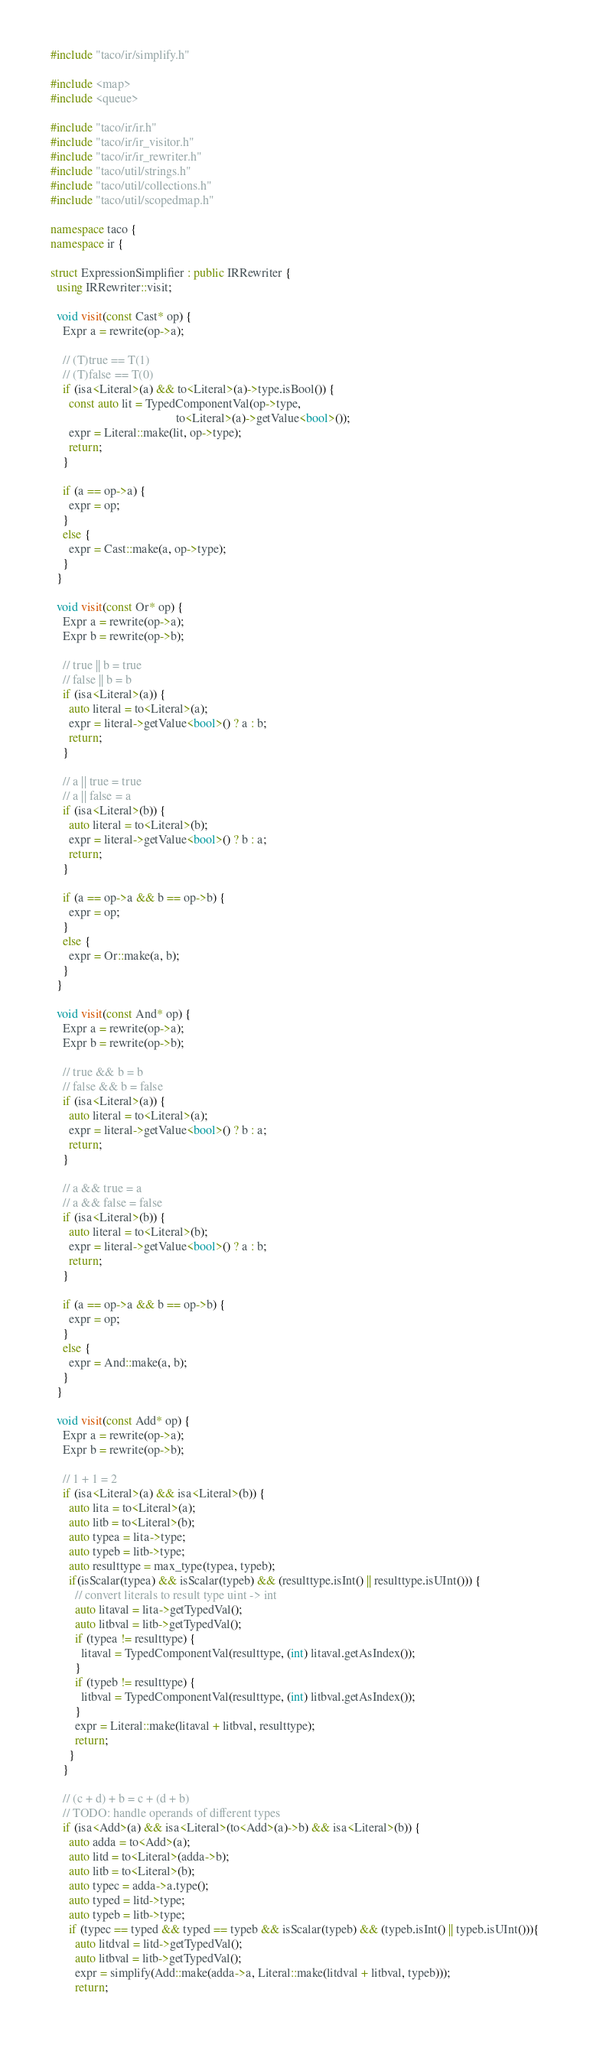Convert code to text. <code><loc_0><loc_0><loc_500><loc_500><_C++_>#include "taco/ir/simplify.h"

#include <map>
#include <queue>

#include "taco/ir/ir.h"
#include "taco/ir/ir_visitor.h"
#include "taco/ir/ir_rewriter.h"
#include "taco/util/strings.h"
#include "taco/util/collections.h"
#include "taco/util/scopedmap.h"

namespace taco {
namespace ir {

struct ExpressionSimplifier : public IRRewriter {
  using IRRewriter::visit;

  void visit(const Cast* op) {
    Expr a = rewrite(op->a);

    // (T)true == T(1)
    // (T)false == T(0)
    if (isa<Literal>(a) && to<Literal>(a)->type.isBool()) {
      const auto lit = TypedComponentVal(op->type, 
                                         to<Literal>(a)->getValue<bool>());
      expr = Literal::make(lit, op->type);
      return;
    }

    if (a == op->a) {
      expr = op;
    }
    else {
      expr = Cast::make(a, op->type);
    }
  }

  void visit(const Or* op) {
    Expr a = rewrite(op->a);
    Expr b = rewrite(op->b);

    // true || b = true
    // false || b = b
    if (isa<Literal>(a)) {
      auto literal = to<Literal>(a);
      expr = literal->getValue<bool>() ? a : b;
      return;
    }

    // a || true = true
    // a || false = a
    if (isa<Literal>(b)) {
      auto literal = to<Literal>(b);
      expr = literal->getValue<bool>() ? b : a;
      return;
    }

    if (a == op->a && b == op->b) {
      expr = op;
    }
    else {
      expr = Or::make(a, b);
    }
  }

  void visit(const And* op) {
    Expr a = rewrite(op->a);
    Expr b = rewrite(op->b);

    // true && b = b
    // false && b = false
    if (isa<Literal>(a)) {
      auto literal = to<Literal>(a);
      expr = literal->getValue<bool>() ? b : a;
      return;
    }

    // a && true = a
    // a && false = false
    if (isa<Literal>(b)) {
      auto literal = to<Literal>(b);
      expr = literal->getValue<bool>() ? a : b;
      return;
    }

    if (a == op->a && b == op->b) {
      expr = op;
    }
    else {
      expr = And::make(a, b);
    }
  }

  void visit(const Add* op) {
    Expr a = rewrite(op->a);
    Expr b = rewrite(op->b);

    // 1 + 1 = 2
    if (isa<Literal>(a) && isa<Literal>(b)) {
      auto lita = to<Literal>(a);
      auto litb = to<Literal>(b);
      auto typea = lita->type;
      auto typeb = litb->type;
      auto resulttype = max_type(typea, typeb);
      if(isScalar(typea) && isScalar(typeb) && (resulttype.isInt() || resulttype.isUInt())) {
        // convert literals to result type uint -> int
        auto litaval = lita->getTypedVal();
        auto litbval = litb->getTypedVal();
        if (typea != resulttype) {
          litaval = TypedComponentVal(resulttype, (int) litaval.getAsIndex());
        }
        if (typeb != resulttype) {
          litbval = TypedComponentVal(resulttype, (int) litbval.getAsIndex());
        }
        expr = Literal::make(litaval + litbval, resulttype);
        return; 
      }
    }

    // (c + d) + b = c + (d + b)
    // TODO: handle operands of different types
    if (isa<Add>(a) && isa<Literal>(to<Add>(a)->b) && isa<Literal>(b)) {
      auto adda = to<Add>(a);
      auto litd = to<Literal>(adda->b);
      auto litb = to<Literal>(b);
      auto typec = adda->a.type();
      auto typed = litd->type;
      auto typeb = litb->type;
      if (typec == typed && typed == typeb && isScalar(typeb) && (typeb.isInt() || typeb.isUInt())){
        auto litdval = litd->getTypedVal();
        auto litbval = litb->getTypedVal();
        expr = simplify(Add::make(adda->a, Literal::make(litdval + litbval, typeb)));
        return;</code> 